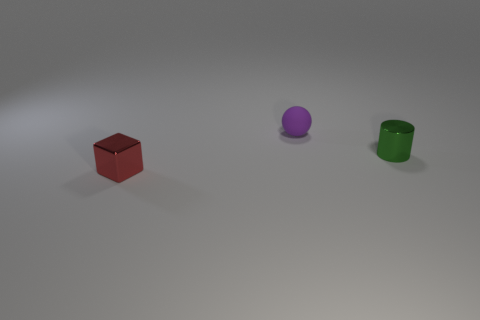Add 1 purple metallic cylinders. How many objects exist? 4 Subtract all cubes. How many objects are left? 2 Add 2 small red things. How many small red things exist? 3 Subtract 0 cyan blocks. How many objects are left? 3 Subtract all big brown matte cylinders. Subtract all small things. How many objects are left? 0 Add 3 tiny shiny blocks. How many tiny shiny blocks are left? 4 